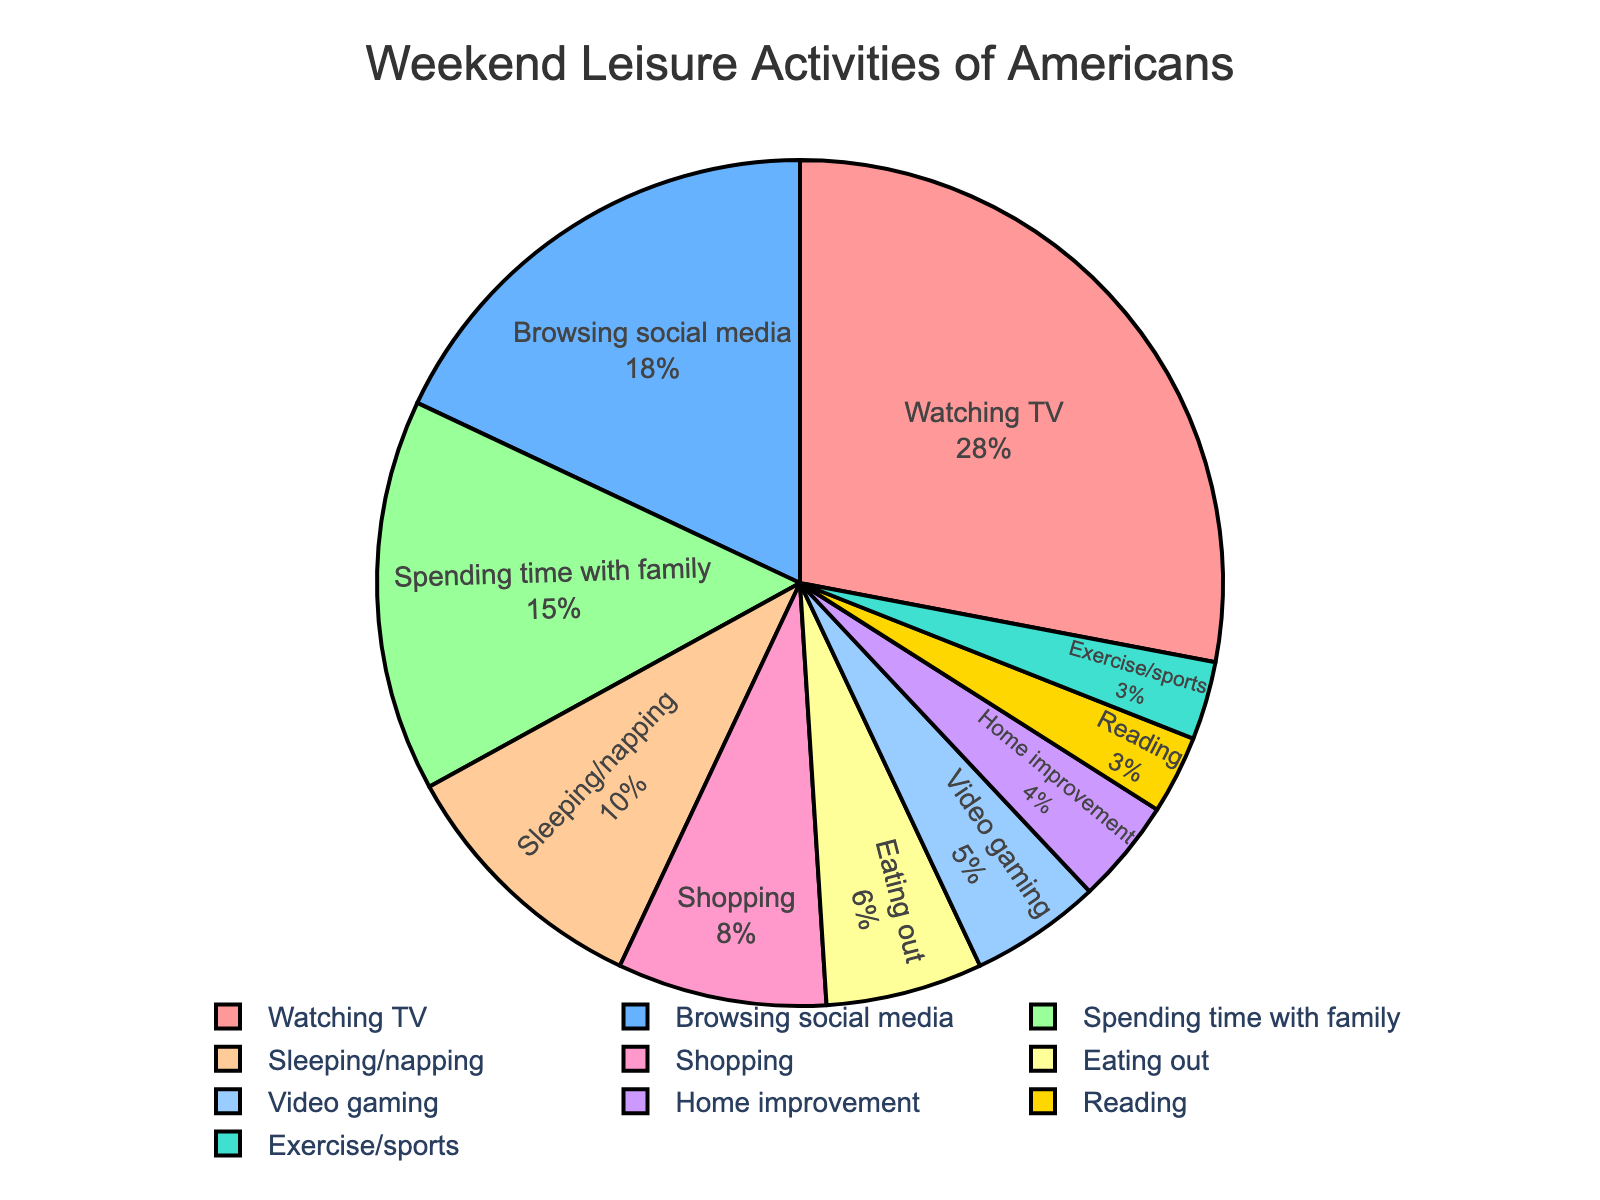What's the largest category of weekend leisure activity for Americans? The slice of the pie chart labeled "Watching TV" is the largest, representing 28%.
Answer: Watching TV Which is more popular, browsing social media or spending time with family? By looking at the pie chart, we see that browsing social media is 18% while spending time with family is 15%. 18% is greater than 15%.
Answer: Browsing social media What percentage of Americans engage in exercise/sports on weekends? The pie chart shows a slice labeled "Exercise/sports," and it is marked with 3%.
Answer: 3% How much more do Americans prefer watching TV over reading? Watching TV is 28% and reading is 3%. The difference is calculated as 28% - 3% = 25%.
Answer: 25% Which activity is the least popular according to the pie chart? The smallest slice of the pie chart is labeled "Reading," representing 3%.
Answer: Reading Do more Americans spend weekends eating out or playing video games? The pie chart shows 6% for eating out and 5% for video gaming. 6% is greater than 5%.
Answer: Eating out What is the combined percentage of Americans who either shop or eat out on weekends? Shopping accounts for 8% and eating out for 6%. The combined percentage is 8% + 6% = 14%.
Answer: 14% Is the percentage of Americans who sleep/napping higher than that of those who improve their homes? Sleeping/napping is represented by 10%, while home improvement is 4%. 10% is greater than 4%.
Answer: Yes How many times more popular is watching TV compared to home improvement? Watching TV has 28% and home improvement has 4%. The ratio is 28% / 4% = 7.
Answer: 7 times If you add the percentages of browsing social media, shopping, and eating out, do they exceed watching TV alone? Browsing social media is 18%, shopping is 8%, and eating out is 6%. Their sum is 18% + 8% + 6% = 32%. Since watching TV alone is 28%, 32% is indeed greater than 28%.
Answer: Yes 